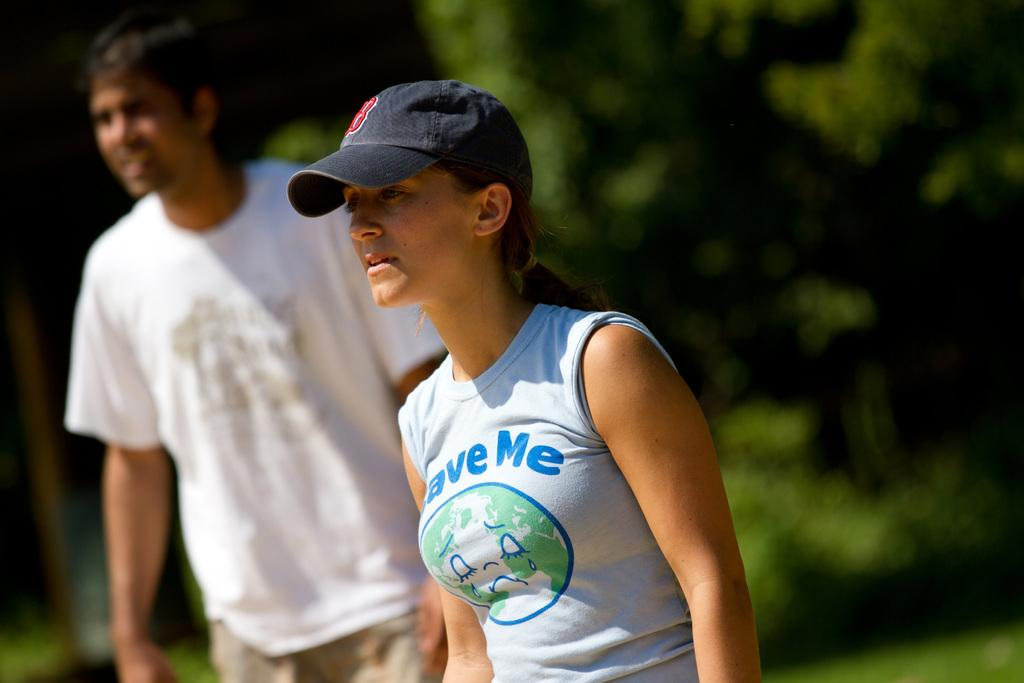Provide a one-sentence caption for the provided image. A young woman sports a blue ball cap and a t-shirt reading Save Me. 